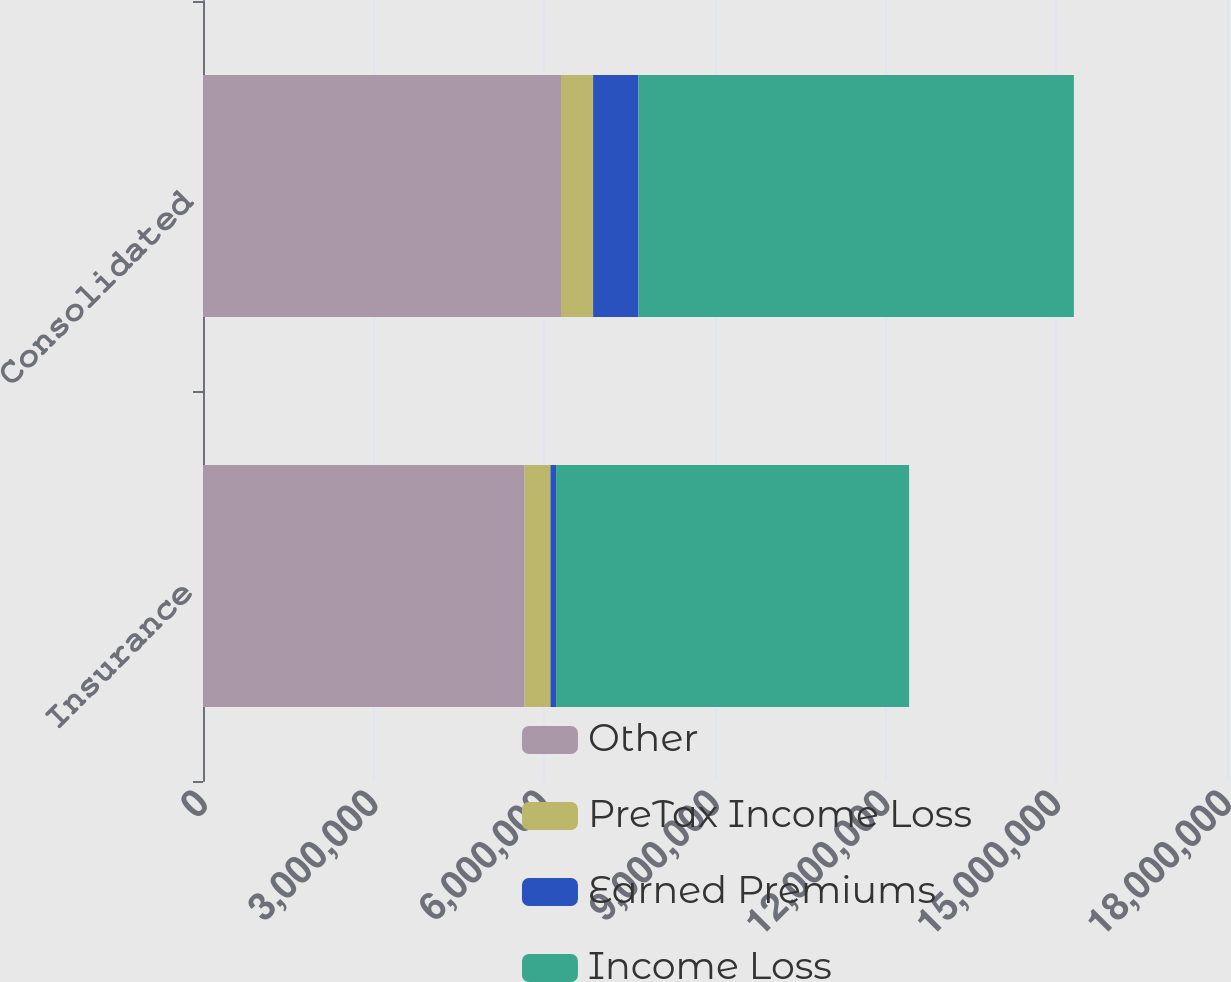Convert chart to OTSL. <chart><loc_0><loc_0><loc_500><loc_500><stacked_bar_chart><ecel><fcel>Insurance<fcel>Consolidated<nl><fcel>Other<fcel>5.6529e+06<fcel>6.29335e+06<nl><fcel>PreTax Income Loss<fcel>455139<fcel>564163<nl><fcel>Earned Premiums<fcel>97879<fcel>796673<nl><fcel>Income Loss<fcel>6.20592e+06<fcel>7.65418e+06<nl></chart> 